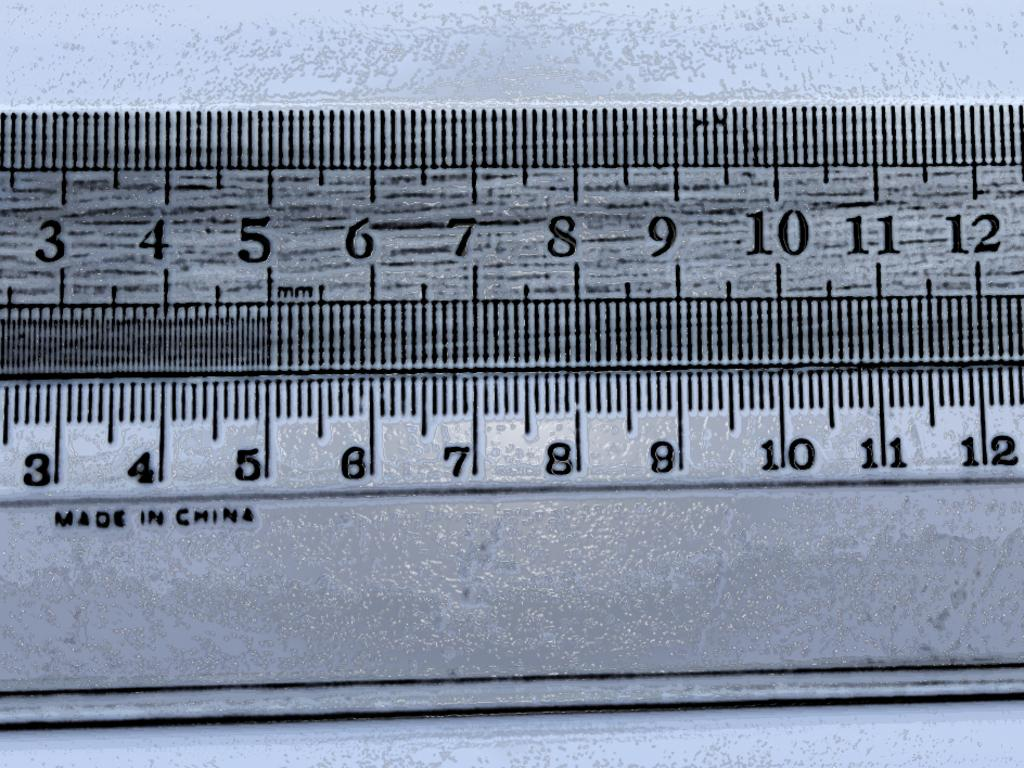<image>
Provide a brief description of the given image. A ruler showing from number 3 to 12 has been made in china. 